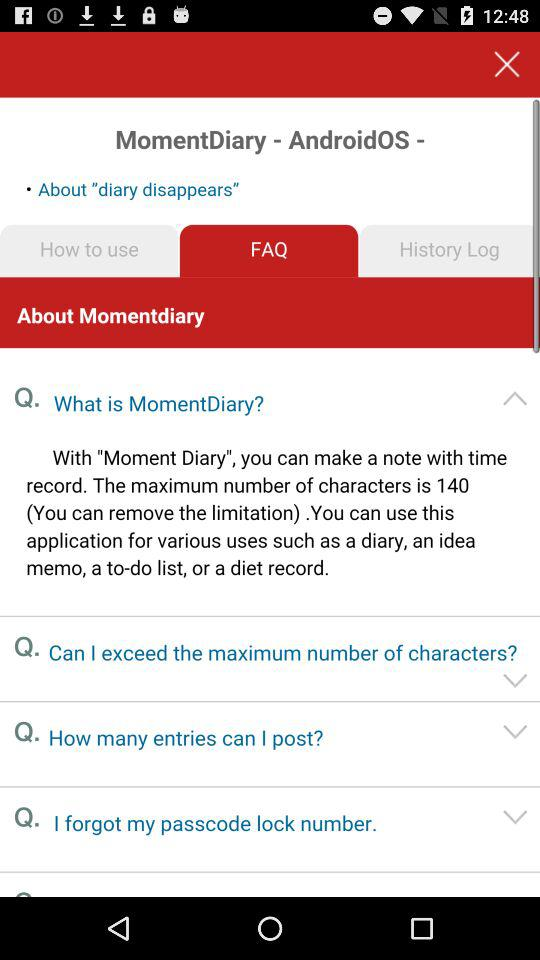Which tab is selected? The selected tab is "FAQ". 